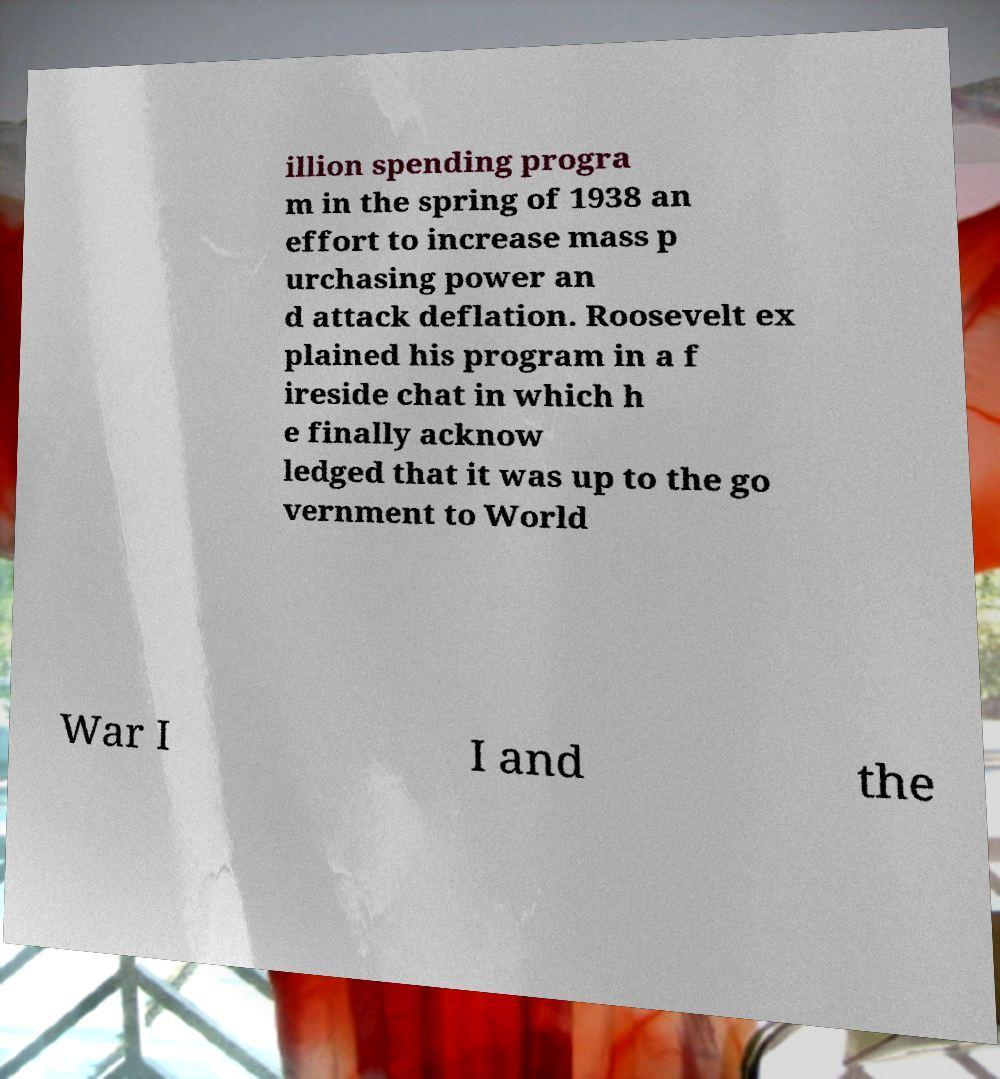I need the written content from this picture converted into text. Can you do that? illion spending progra m in the spring of 1938 an effort to increase mass p urchasing power an d attack deflation. Roosevelt ex plained his program in a f ireside chat in which h e finally acknow ledged that it was up to the go vernment to World War I I and the 